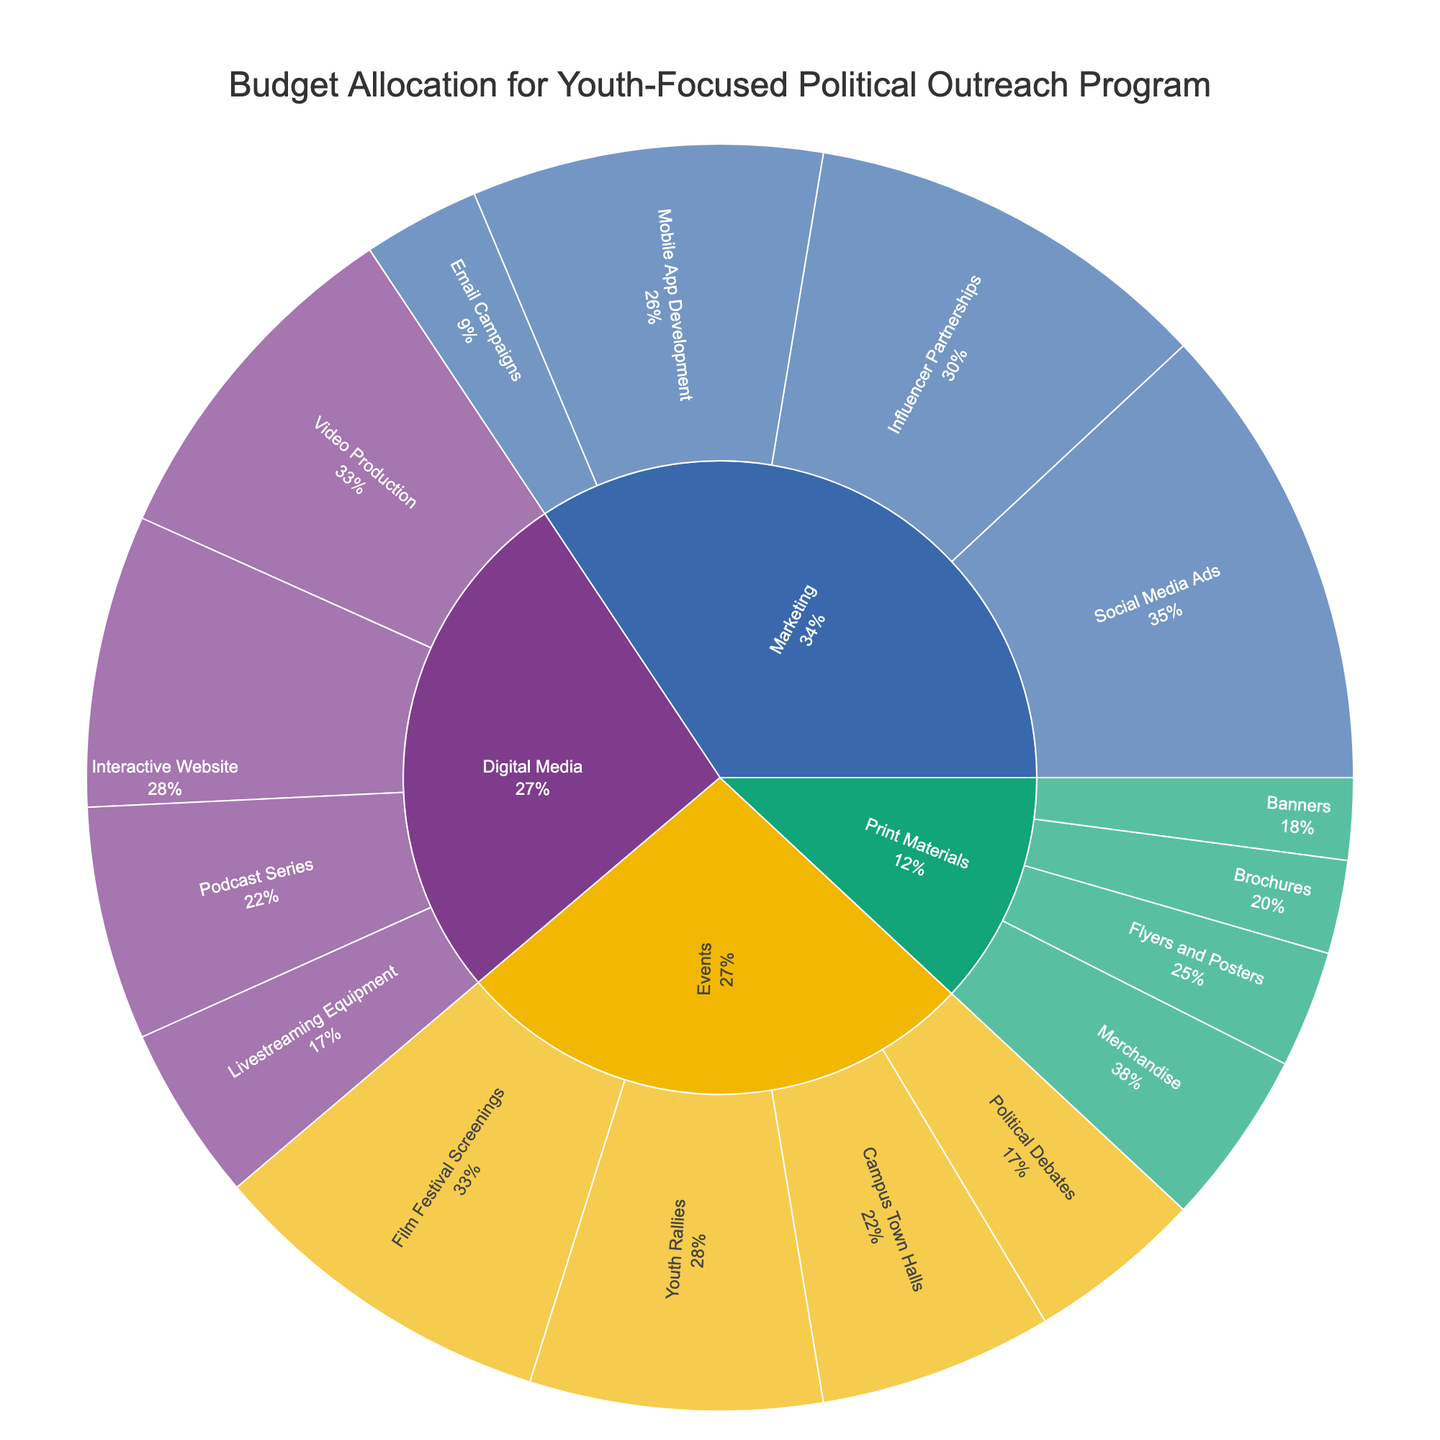What is the title of the chart? The title is usually displayed prominently at the top of the chart to provide a quick understanding of what the chart represents.
Answer: Budget Allocation for Youth-Focused Political Outreach Program Which category has the highest budget allocation? Look at the outermost ring of the sunburst plot to see which category segment is the largest.
Answer: Marketing What is the budget allocation for Campus Town Halls as a percentage of the Events category? Find the Campus Town Halls segment within the Events category on the sunburst plot and check the percentage value indicated.
Answer: 20% What is the total budget allocated for Print Materials? Sum all subcategory values under Print Materials: Flyers and Posters (10,000), Brochures (8,000), Banners (7,000), Merchandise (15,000).
Answer: $40,000 How does the budget for Social Media Ads compare to the budget for Influencer Partnerships? Locate both segments under Marketing and compare their values. Social Media Ads have a higher value than Influencer Partnerships.
Answer: Social Media Ads have a higher budget What percentage of the total budget is allocated to Digital Media? Find the overall size of the Digital Media segment by summing its subcategories' percentages.
Answer: 24% Which subcategory within Digital Media has the largest budget? Within the Digital Media category on the sunburst plot, identify which segment occupies the largest space.
Answer: Video Production How does the total budget for Events compare to the total budget for Marketing? Sum the budgets for all subcategories under Events and compare to the sum of all subcategories under Marketing. Events total: 90,000, Marketing total: 115,000.
Answer: Marketing has a higher budget What is the total budget allocation for all categories combined? Sum all subcategory values under each category: Events (90,000), Marketing (115,000), Digital Media (90,000), Print Materials (40,000).
Answer: $335,000 What is the least funded subcategory within Print Materials and what is its percentage of the Print Materials budget? Find the smallest segment within Print Materials on the sunburst plot and calculate its percentage out of the total Print Materials budget. Brochures have the smallest budget of $8,000, which is 20% of the total Print Materials budget.
Answer: Brochures, 20% 